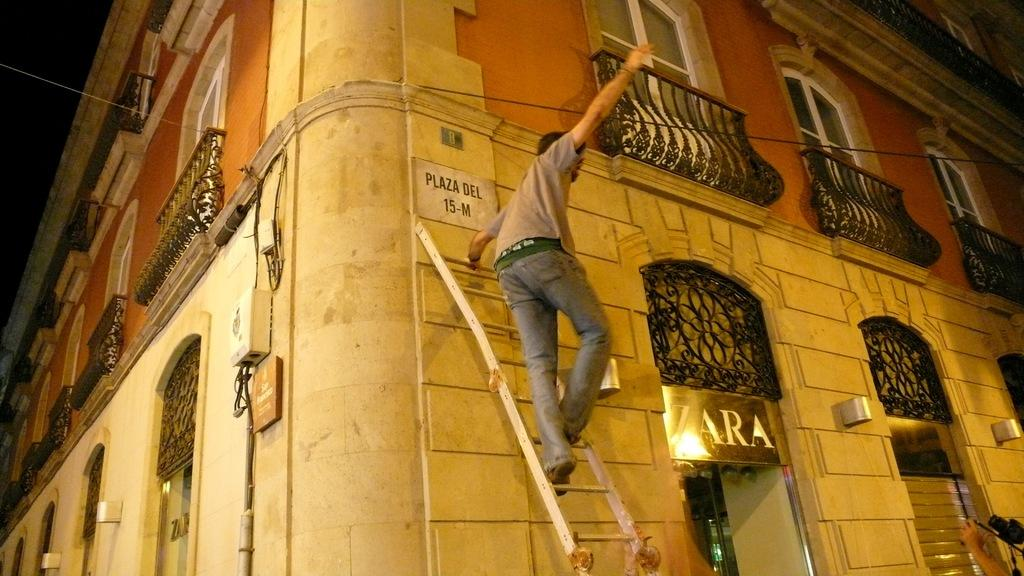What is the person in the image doing? The person is standing on a ladder. Where is the person located in relation to the building? The person is near a building. What feature of the building can be seen in the image? The building has windows. What type of lettuce is being used to cry by the person on the ladder? There is no lettuce or indication of crying in the image; the person is simply standing on a ladder near a building. 